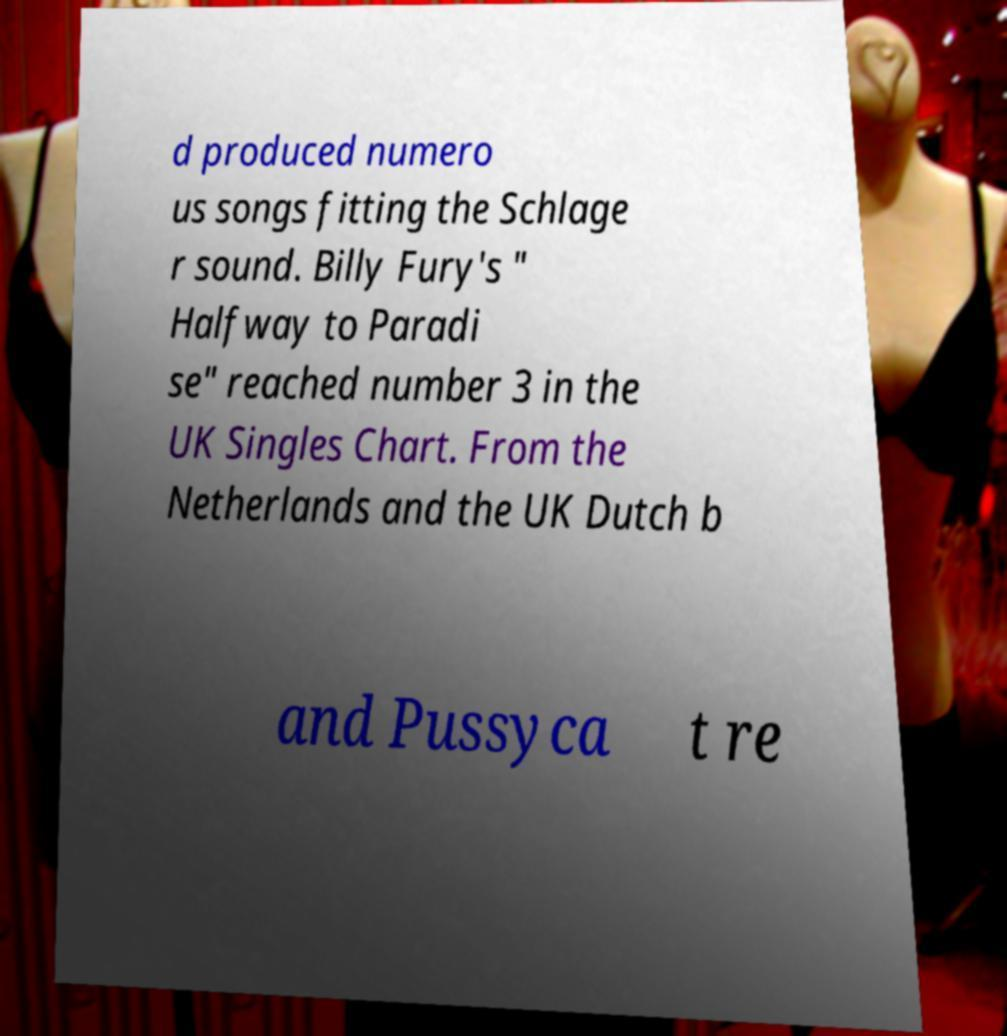Could you extract and type out the text from this image? d produced numero us songs fitting the Schlage r sound. Billy Fury's " Halfway to Paradi se" reached number 3 in the UK Singles Chart. From the Netherlands and the UK Dutch b and Pussyca t re 